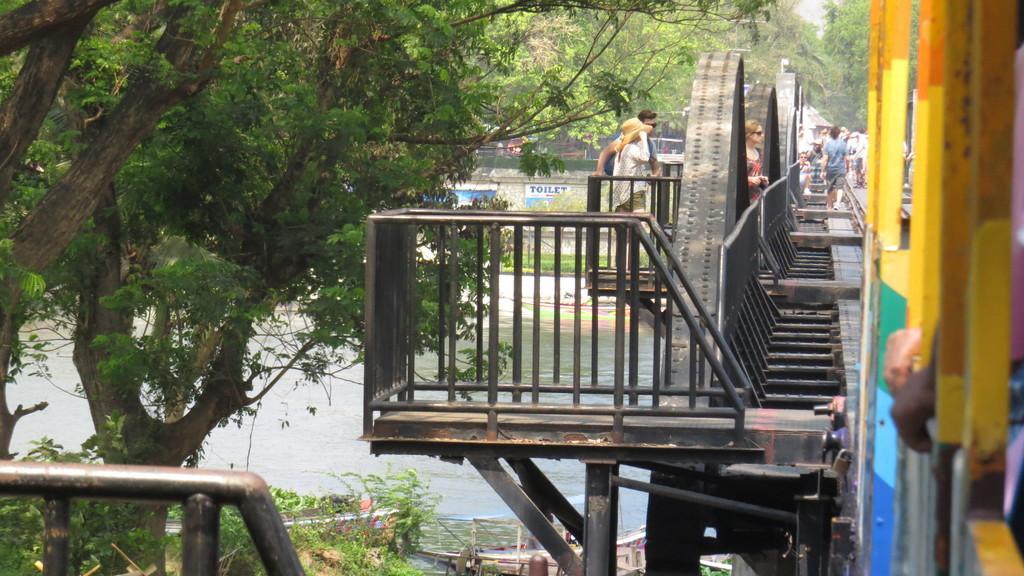In one or two sentences, can you explain what this image depicts? In this picture we can see a stand and a few trees on the left side. There is water. We can see a few people on the path on the right side. There are some trees and other objects are visible in the background. 